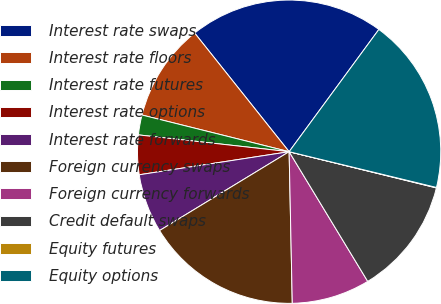Convert chart to OTSL. <chart><loc_0><loc_0><loc_500><loc_500><pie_chart><fcel>Interest rate swaps<fcel>Interest rate floors<fcel>Interest rate futures<fcel>Interest rate options<fcel>Interest rate forwards<fcel>Foreign currency swaps<fcel>Foreign currency forwards<fcel>Credit default swaps<fcel>Equity futures<fcel>Equity options<nl><fcel>20.78%<fcel>10.41%<fcel>2.12%<fcel>4.2%<fcel>6.27%<fcel>16.63%<fcel>8.34%<fcel>12.49%<fcel>0.05%<fcel>18.71%<nl></chart> 